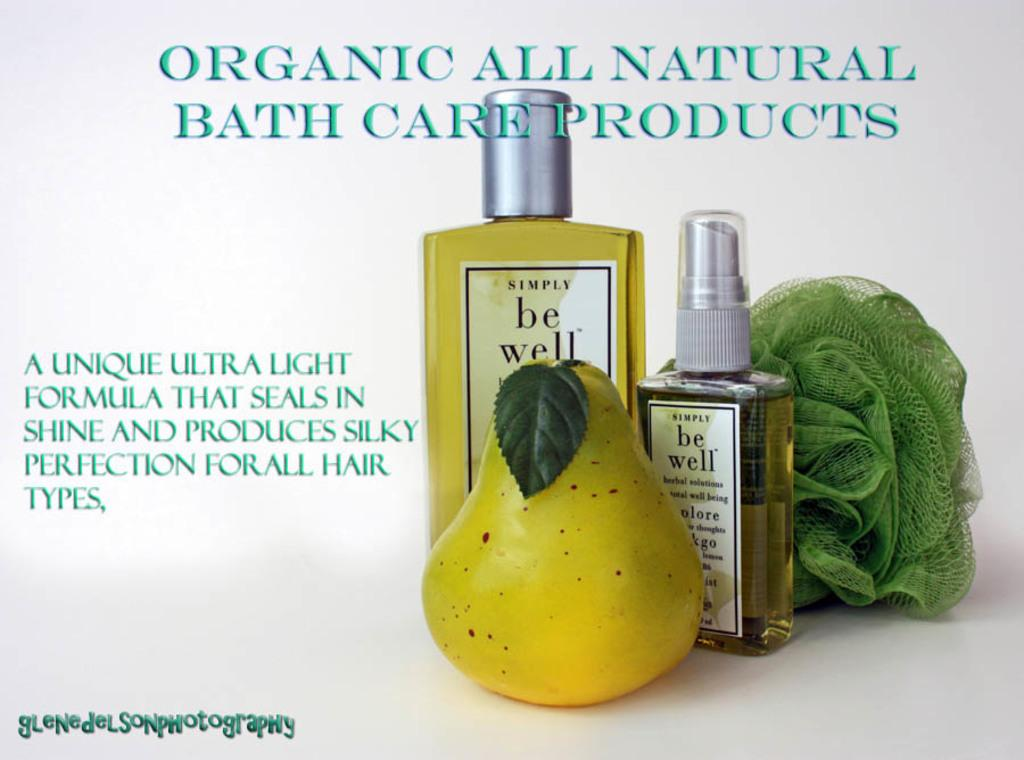<image>
Offer a succinct explanation of the picture presented. Two bottles of be well are on a table with a sponge and a type of fruit. 